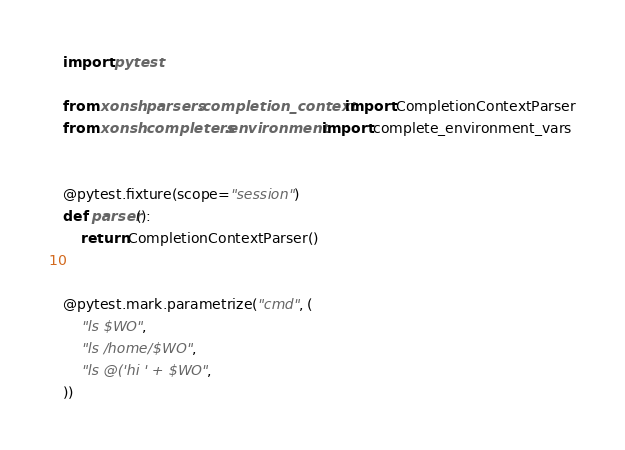Convert code to text. <code><loc_0><loc_0><loc_500><loc_500><_Python_>import pytest

from xonsh.parsers.completion_context import CompletionContextParser
from xonsh.completers.environment import complete_environment_vars


@pytest.fixture(scope="session")
def parser():
    return CompletionContextParser()


@pytest.mark.parametrize("cmd", (
    "ls $WO",
    "ls /home/$WO",
    "ls @('hi ' + $WO",
))</code> 